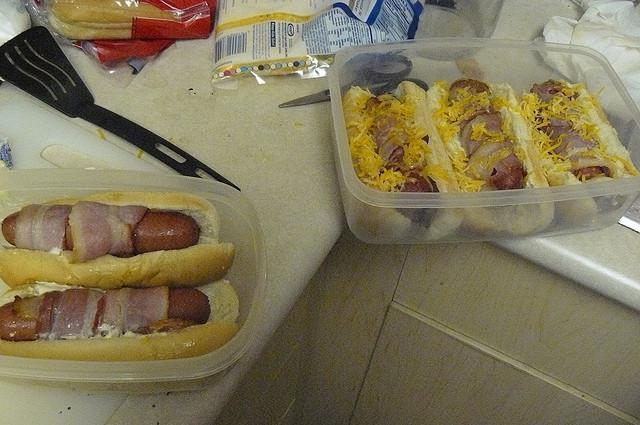How many hot dogs are there?
Give a very brief answer. 5. How many hot dogs can you see?
Give a very brief answer. 5. How many bowls are there?
Give a very brief answer. 2. How many people are wearing a blue helmet?
Give a very brief answer. 0. 